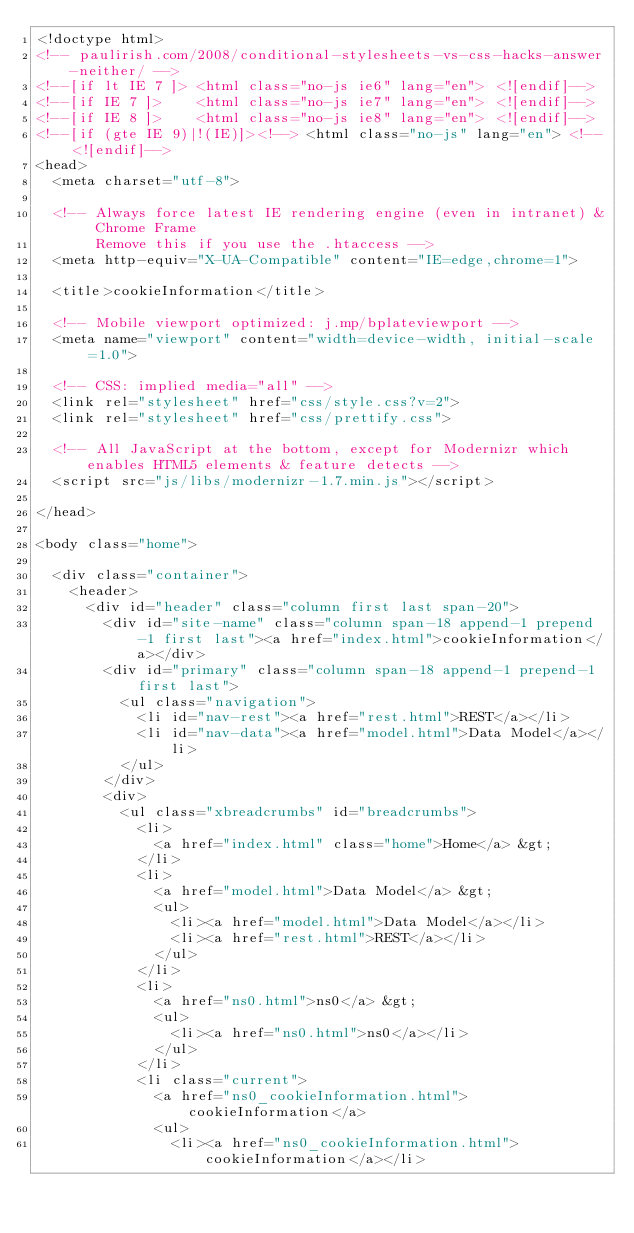Convert code to text. <code><loc_0><loc_0><loc_500><loc_500><_HTML_><!doctype html>
<!-- paulirish.com/2008/conditional-stylesheets-vs-css-hacks-answer-neither/ -->
<!--[if lt IE 7 ]> <html class="no-js ie6" lang="en"> <![endif]-->
<!--[if IE 7 ]>    <html class="no-js ie7" lang="en"> <![endif]-->
<!--[if IE 8 ]>    <html class="no-js ie8" lang="en"> <![endif]-->
<!--[if (gte IE 9)|!(IE)]><!--> <html class="no-js" lang="en"> <!--<![endif]-->
<head>
  <meta charset="utf-8">

  <!-- Always force latest IE rendering engine (even in intranet) & Chrome Frame
       Remove this if you use the .htaccess -->
  <meta http-equiv="X-UA-Compatible" content="IE=edge,chrome=1">

  <title>cookieInformation</title>

  <!-- Mobile viewport optimized: j.mp/bplateviewport -->
  <meta name="viewport" content="width=device-width, initial-scale=1.0">

  <!-- CSS: implied media="all" -->
  <link rel="stylesheet" href="css/style.css?v=2">
  <link rel="stylesheet" href="css/prettify.css">

  <!-- All JavaScript at the bottom, except for Modernizr which enables HTML5 elements & feature detects -->
  <script src="js/libs/modernizr-1.7.min.js"></script>

</head>

<body class="home">

  <div class="container">
    <header>
      <div id="header" class="column first last span-20">
        <div id="site-name" class="column span-18 append-1 prepend-1 first last"><a href="index.html">cookieInformation</a></div>
        <div id="primary" class="column span-18 append-1 prepend-1 first last">
          <ul class="navigation">
            <li id="nav-rest"><a href="rest.html">REST</a></li>
            <li id="nav-data"><a href="model.html">Data Model</a></li>
          </ul>
        </div>
        <div>
          <ul class="xbreadcrumbs" id="breadcrumbs">
            <li>
              <a href="index.html" class="home">Home</a> &gt;
            </li>
            <li>
              <a href="model.html">Data Model</a> &gt;
              <ul>
                <li><a href="model.html">Data Model</a></li>
                <li><a href="rest.html">REST</a></li>
              </ul>
            </li>
            <li>
              <a href="ns0.html">ns0</a> &gt;
              <ul>
                <li><a href="ns0.html">ns0</a></li>
              </ul>
            </li>
            <li class="current">
              <a href="ns0_cookieInformation.html">cookieInformation</a>
              <ul>
                <li><a href="ns0_cookieInformation.html">cookieInformation</a></li></code> 